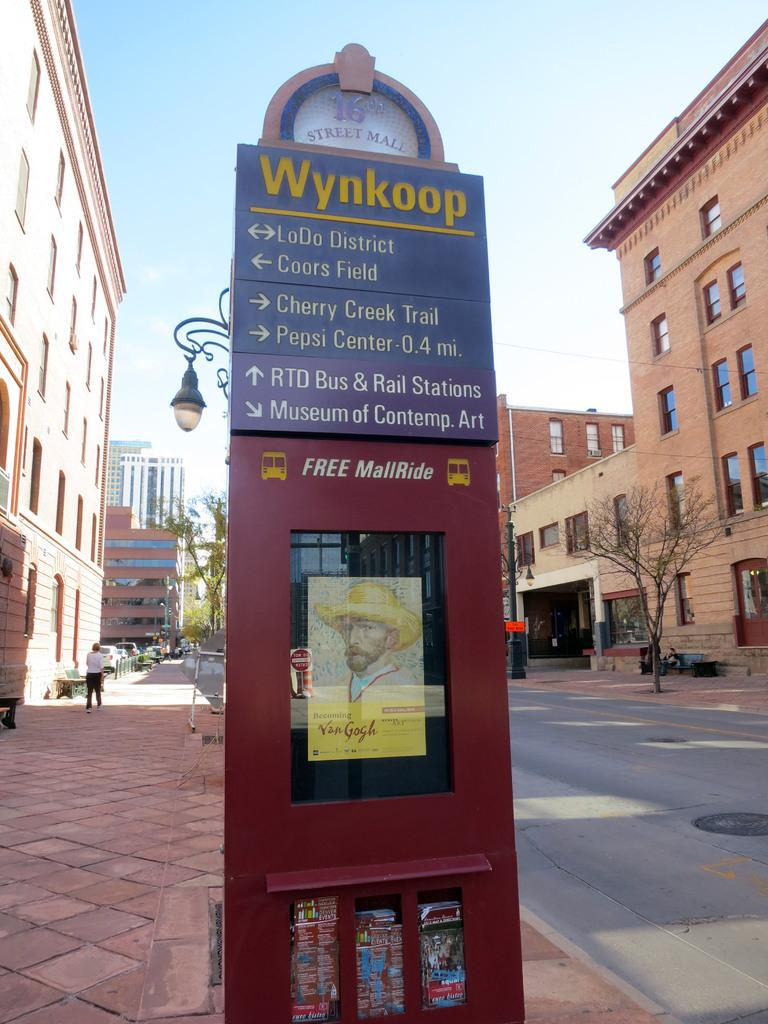What is the main object in the middle of the image? There is a board in the middle of the image. What can be seen on both sides of the board? There are buildings on either side of the road. What type of vegetation is present on the right side of the image? There is a tree on the right side of the image. What type of flight can be seen taking off from the board in the image? There is no flight present in the image; it only features a board, buildings, and a tree. What shape is the tree on the right side of the image? The shape of the tree cannot be determined from the image alone, as it only provides a general view of the tree. 